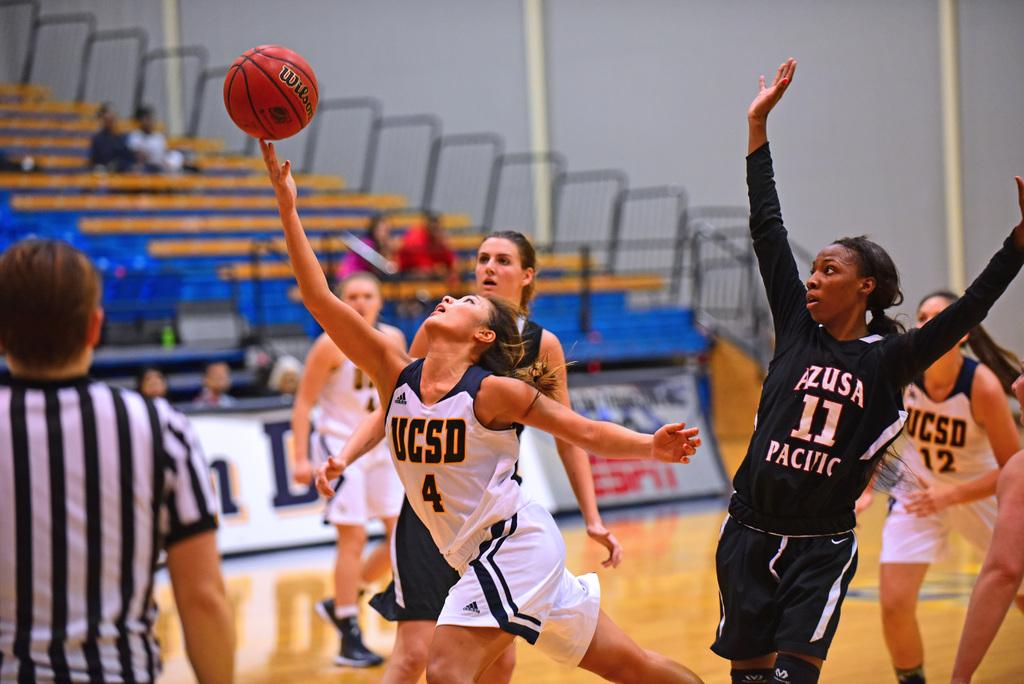What teams are playing?
Ensure brevity in your answer.  Ucsd and azusa pacific. What number is on the black shirt?
Your answer should be compact. 11. 